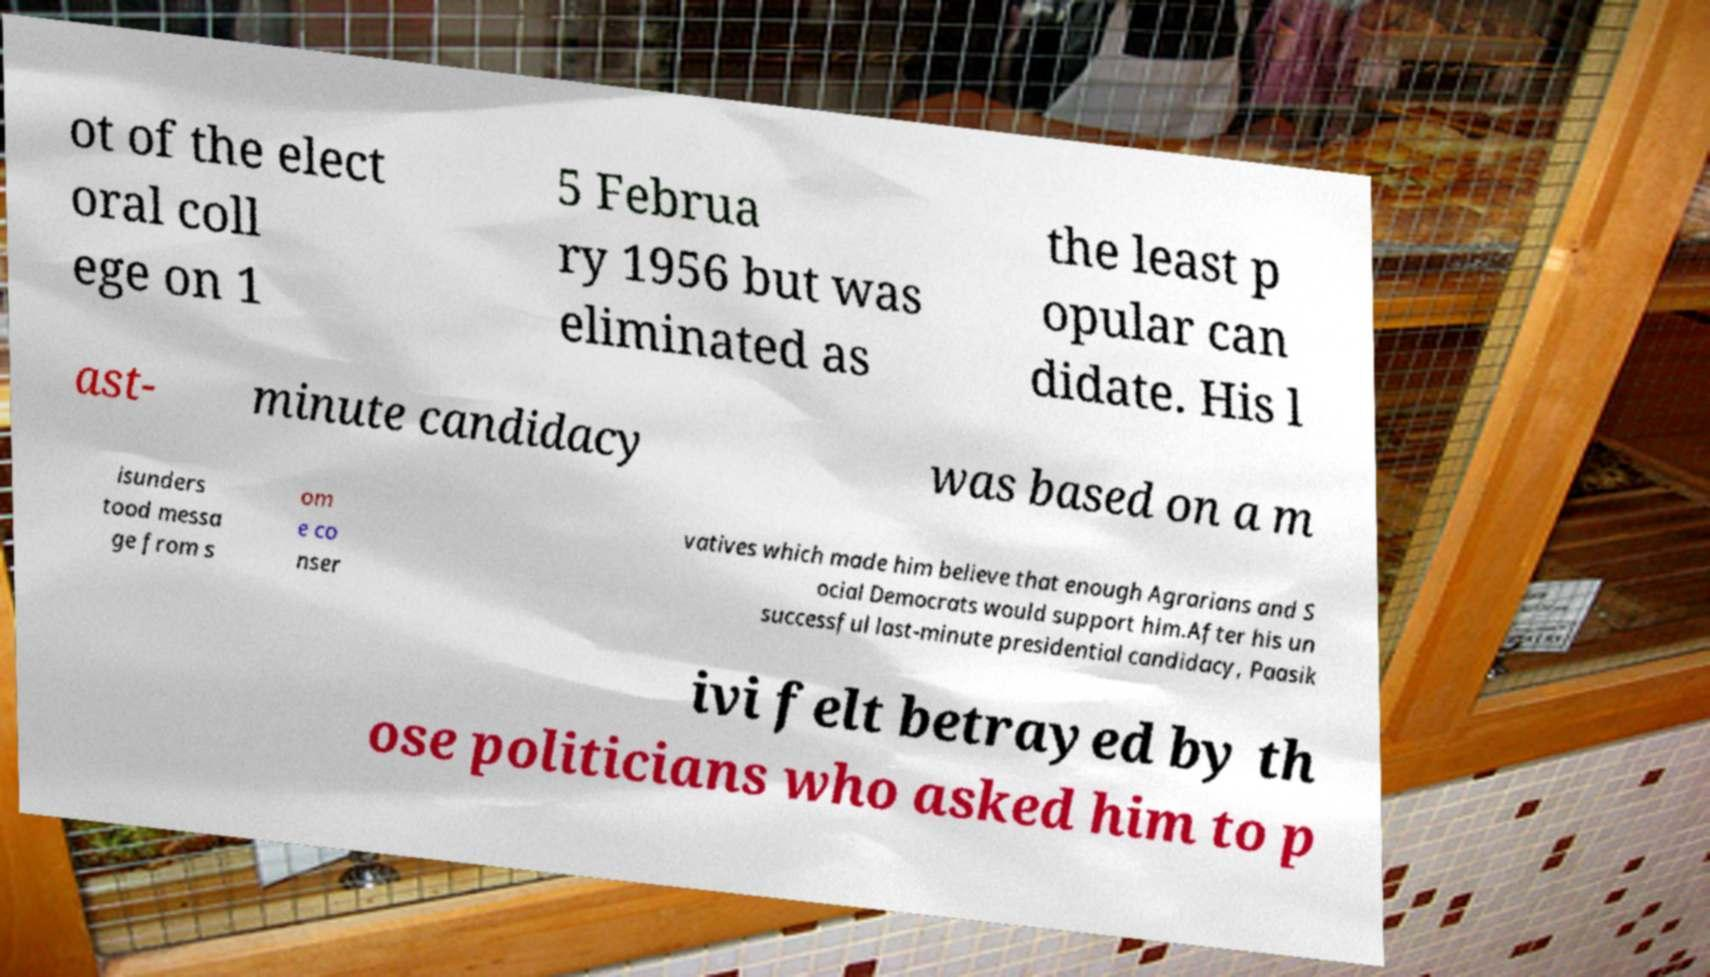Can you accurately transcribe the text from the provided image for me? ot of the elect oral coll ege on 1 5 Februa ry 1956 but was eliminated as the least p opular can didate. His l ast- minute candidacy was based on a m isunders tood messa ge from s om e co nser vatives which made him believe that enough Agrarians and S ocial Democrats would support him.After his un successful last-minute presidential candidacy, Paasik ivi felt betrayed by th ose politicians who asked him to p 